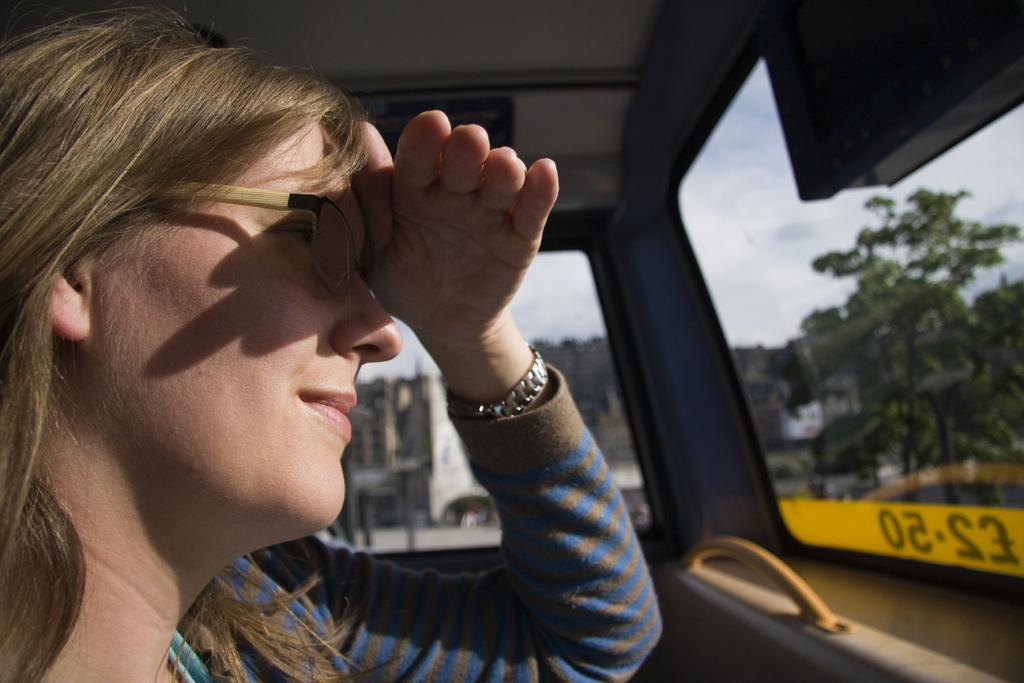Who is present in the image? There is a woman in the image. What is the woman wearing on her face? The woman is wearing spectacles. What expression does the woman have? The woman is smiling. What can be seen in the background of the image? There are buildings, trees, and the sky visible in the background of the image. What is the condition of the sky in the image? Clouds are present in the sky. What type of skirt is the woman wearing in the image? The provided facts do not mention a skirt; the woman is wearing spectacles. What is the woman's level of fear in the image? The provided facts do not mention fear; the woman is smiling. 